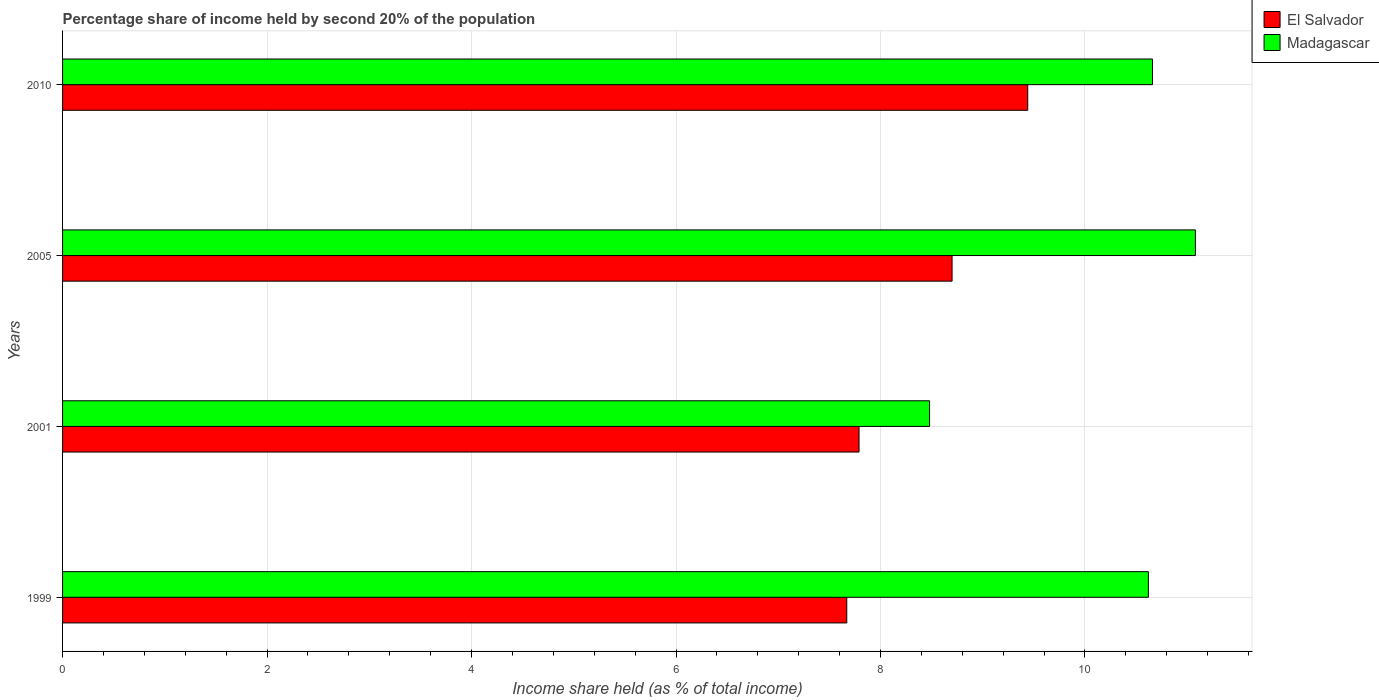How many groups of bars are there?
Keep it short and to the point. 4. How many bars are there on the 4th tick from the top?
Provide a short and direct response. 2. What is the label of the 2nd group of bars from the top?
Your response must be concise. 2005. What is the share of income held by second 20% of the population in El Salvador in 2001?
Your answer should be very brief. 7.79. Across all years, what is the maximum share of income held by second 20% of the population in Madagascar?
Give a very brief answer. 11.08. Across all years, what is the minimum share of income held by second 20% of the population in Madagascar?
Give a very brief answer. 8.48. In which year was the share of income held by second 20% of the population in Madagascar minimum?
Your answer should be very brief. 2001. What is the total share of income held by second 20% of the population in Madagascar in the graph?
Offer a very short reply. 40.84. What is the difference between the share of income held by second 20% of the population in Madagascar in 2005 and that in 2010?
Your answer should be compact. 0.42. What is the difference between the share of income held by second 20% of the population in El Salvador in 2005 and the share of income held by second 20% of the population in Madagascar in 1999?
Ensure brevity in your answer.  -1.92. In the year 2010, what is the difference between the share of income held by second 20% of the population in El Salvador and share of income held by second 20% of the population in Madagascar?
Your answer should be very brief. -1.22. In how many years, is the share of income held by second 20% of the population in Madagascar greater than 6.8 %?
Provide a short and direct response. 4. What is the ratio of the share of income held by second 20% of the population in El Salvador in 1999 to that in 2010?
Offer a very short reply. 0.81. Is the difference between the share of income held by second 20% of the population in El Salvador in 1999 and 2005 greater than the difference between the share of income held by second 20% of the population in Madagascar in 1999 and 2005?
Provide a short and direct response. No. What is the difference between the highest and the second highest share of income held by second 20% of the population in Madagascar?
Offer a very short reply. 0.42. What is the difference between the highest and the lowest share of income held by second 20% of the population in Madagascar?
Provide a short and direct response. 2.6. Is the sum of the share of income held by second 20% of the population in El Salvador in 2001 and 2005 greater than the maximum share of income held by second 20% of the population in Madagascar across all years?
Give a very brief answer. Yes. What does the 2nd bar from the top in 2001 represents?
Offer a terse response. El Salvador. What does the 2nd bar from the bottom in 1999 represents?
Offer a terse response. Madagascar. How many bars are there?
Offer a very short reply. 8. Are the values on the major ticks of X-axis written in scientific E-notation?
Ensure brevity in your answer.  No. Does the graph contain grids?
Provide a short and direct response. Yes. Where does the legend appear in the graph?
Your answer should be very brief. Top right. How many legend labels are there?
Offer a terse response. 2. What is the title of the graph?
Offer a terse response. Percentage share of income held by second 20% of the population. Does "Congo (Democratic)" appear as one of the legend labels in the graph?
Offer a terse response. No. What is the label or title of the X-axis?
Offer a very short reply. Income share held (as % of total income). What is the Income share held (as % of total income) in El Salvador in 1999?
Your answer should be compact. 7.67. What is the Income share held (as % of total income) of Madagascar in 1999?
Give a very brief answer. 10.62. What is the Income share held (as % of total income) in El Salvador in 2001?
Offer a terse response. 7.79. What is the Income share held (as % of total income) in Madagascar in 2001?
Provide a succinct answer. 8.48. What is the Income share held (as % of total income) of Madagascar in 2005?
Give a very brief answer. 11.08. What is the Income share held (as % of total income) in El Salvador in 2010?
Offer a terse response. 9.44. What is the Income share held (as % of total income) of Madagascar in 2010?
Give a very brief answer. 10.66. Across all years, what is the maximum Income share held (as % of total income) in El Salvador?
Ensure brevity in your answer.  9.44. Across all years, what is the maximum Income share held (as % of total income) of Madagascar?
Make the answer very short. 11.08. Across all years, what is the minimum Income share held (as % of total income) of El Salvador?
Your answer should be compact. 7.67. Across all years, what is the minimum Income share held (as % of total income) of Madagascar?
Give a very brief answer. 8.48. What is the total Income share held (as % of total income) in El Salvador in the graph?
Your answer should be very brief. 33.6. What is the total Income share held (as % of total income) of Madagascar in the graph?
Ensure brevity in your answer.  40.84. What is the difference between the Income share held (as % of total income) of El Salvador in 1999 and that in 2001?
Provide a short and direct response. -0.12. What is the difference between the Income share held (as % of total income) in Madagascar in 1999 and that in 2001?
Give a very brief answer. 2.14. What is the difference between the Income share held (as % of total income) in El Salvador in 1999 and that in 2005?
Ensure brevity in your answer.  -1.03. What is the difference between the Income share held (as % of total income) of Madagascar in 1999 and that in 2005?
Make the answer very short. -0.46. What is the difference between the Income share held (as % of total income) in El Salvador in 1999 and that in 2010?
Offer a terse response. -1.77. What is the difference between the Income share held (as % of total income) in Madagascar in 1999 and that in 2010?
Give a very brief answer. -0.04. What is the difference between the Income share held (as % of total income) in El Salvador in 2001 and that in 2005?
Provide a short and direct response. -0.91. What is the difference between the Income share held (as % of total income) of Madagascar in 2001 and that in 2005?
Give a very brief answer. -2.6. What is the difference between the Income share held (as % of total income) of El Salvador in 2001 and that in 2010?
Give a very brief answer. -1.65. What is the difference between the Income share held (as % of total income) in Madagascar in 2001 and that in 2010?
Make the answer very short. -2.18. What is the difference between the Income share held (as % of total income) of El Salvador in 2005 and that in 2010?
Ensure brevity in your answer.  -0.74. What is the difference between the Income share held (as % of total income) in Madagascar in 2005 and that in 2010?
Provide a succinct answer. 0.42. What is the difference between the Income share held (as % of total income) of El Salvador in 1999 and the Income share held (as % of total income) of Madagascar in 2001?
Provide a succinct answer. -0.81. What is the difference between the Income share held (as % of total income) in El Salvador in 1999 and the Income share held (as % of total income) in Madagascar in 2005?
Your answer should be compact. -3.41. What is the difference between the Income share held (as % of total income) of El Salvador in 1999 and the Income share held (as % of total income) of Madagascar in 2010?
Provide a succinct answer. -2.99. What is the difference between the Income share held (as % of total income) in El Salvador in 2001 and the Income share held (as % of total income) in Madagascar in 2005?
Your response must be concise. -3.29. What is the difference between the Income share held (as % of total income) in El Salvador in 2001 and the Income share held (as % of total income) in Madagascar in 2010?
Ensure brevity in your answer.  -2.87. What is the difference between the Income share held (as % of total income) in El Salvador in 2005 and the Income share held (as % of total income) in Madagascar in 2010?
Give a very brief answer. -1.96. What is the average Income share held (as % of total income) in El Salvador per year?
Provide a succinct answer. 8.4. What is the average Income share held (as % of total income) in Madagascar per year?
Keep it short and to the point. 10.21. In the year 1999, what is the difference between the Income share held (as % of total income) of El Salvador and Income share held (as % of total income) of Madagascar?
Your answer should be very brief. -2.95. In the year 2001, what is the difference between the Income share held (as % of total income) of El Salvador and Income share held (as % of total income) of Madagascar?
Keep it short and to the point. -0.69. In the year 2005, what is the difference between the Income share held (as % of total income) in El Salvador and Income share held (as % of total income) in Madagascar?
Your response must be concise. -2.38. In the year 2010, what is the difference between the Income share held (as % of total income) in El Salvador and Income share held (as % of total income) in Madagascar?
Offer a very short reply. -1.22. What is the ratio of the Income share held (as % of total income) of El Salvador in 1999 to that in 2001?
Provide a succinct answer. 0.98. What is the ratio of the Income share held (as % of total income) in Madagascar in 1999 to that in 2001?
Provide a short and direct response. 1.25. What is the ratio of the Income share held (as % of total income) in El Salvador in 1999 to that in 2005?
Give a very brief answer. 0.88. What is the ratio of the Income share held (as % of total income) of Madagascar in 1999 to that in 2005?
Give a very brief answer. 0.96. What is the ratio of the Income share held (as % of total income) in El Salvador in 1999 to that in 2010?
Offer a very short reply. 0.81. What is the ratio of the Income share held (as % of total income) in Madagascar in 1999 to that in 2010?
Keep it short and to the point. 1. What is the ratio of the Income share held (as % of total income) in El Salvador in 2001 to that in 2005?
Keep it short and to the point. 0.9. What is the ratio of the Income share held (as % of total income) of Madagascar in 2001 to that in 2005?
Your answer should be very brief. 0.77. What is the ratio of the Income share held (as % of total income) in El Salvador in 2001 to that in 2010?
Offer a terse response. 0.83. What is the ratio of the Income share held (as % of total income) of Madagascar in 2001 to that in 2010?
Your answer should be very brief. 0.8. What is the ratio of the Income share held (as % of total income) of El Salvador in 2005 to that in 2010?
Offer a very short reply. 0.92. What is the ratio of the Income share held (as % of total income) in Madagascar in 2005 to that in 2010?
Your answer should be compact. 1.04. What is the difference between the highest and the second highest Income share held (as % of total income) of El Salvador?
Your answer should be very brief. 0.74. What is the difference between the highest and the second highest Income share held (as % of total income) of Madagascar?
Ensure brevity in your answer.  0.42. What is the difference between the highest and the lowest Income share held (as % of total income) in El Salvador?
Make the answer very short. 1.77. 